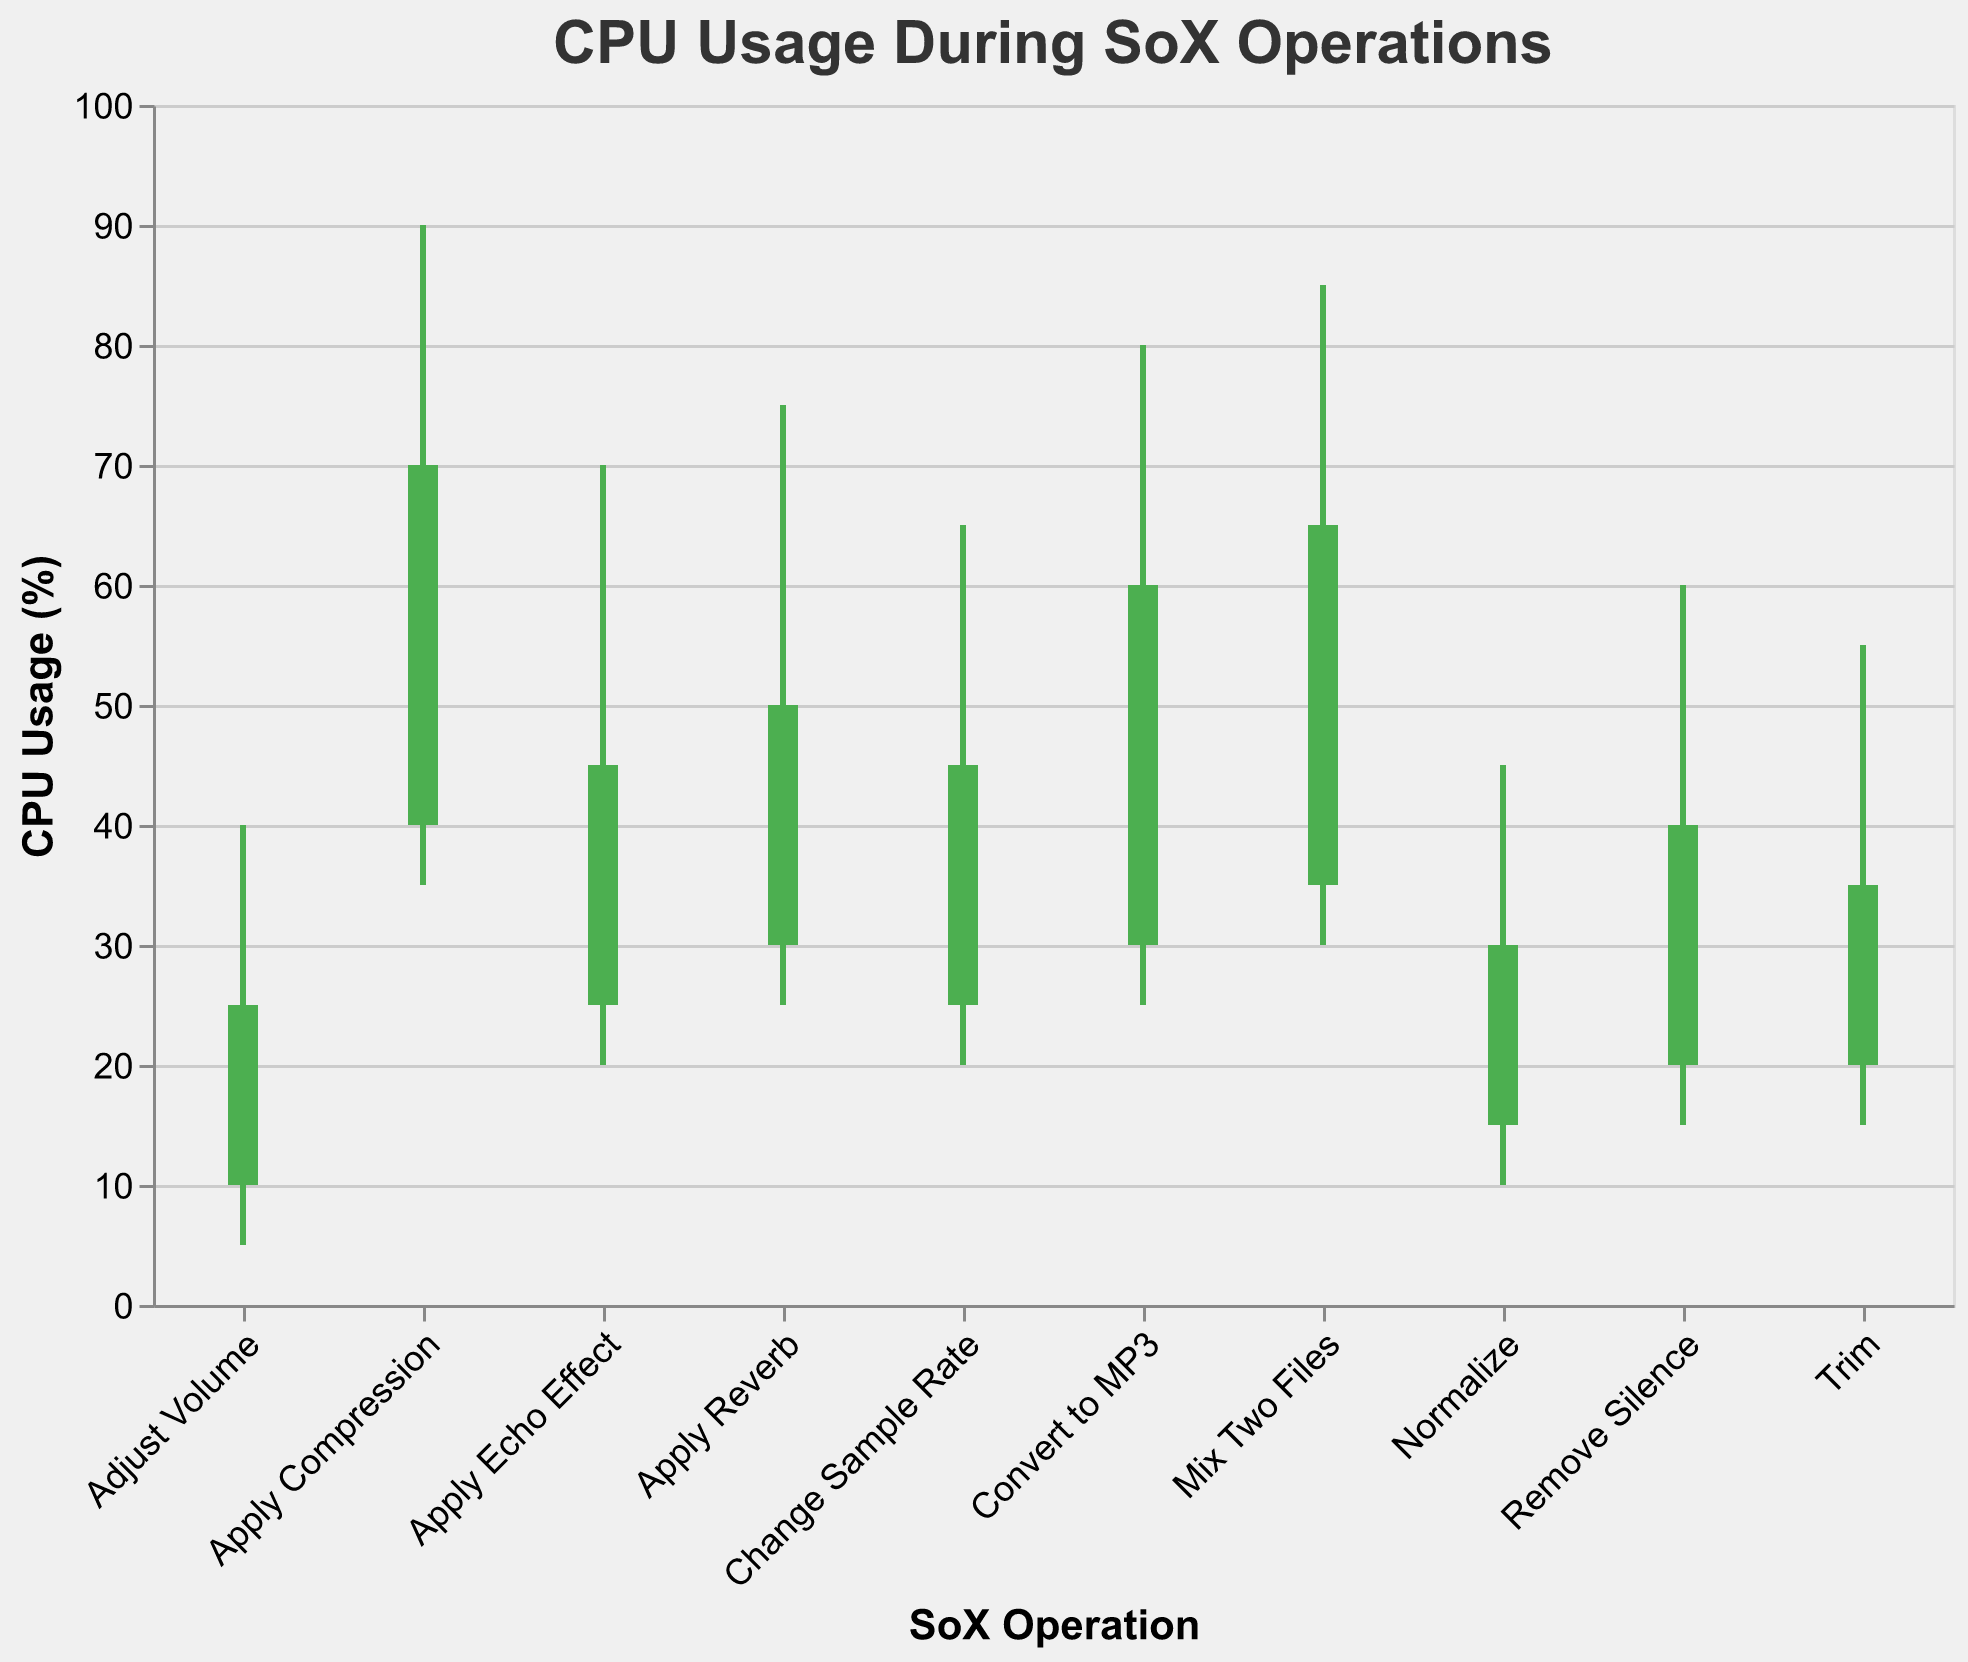What is the title of the chart? The title is prominently displayed at the top of the chart and reads "CPU Usage During SoX Operations".
Answer: CPU Usage During SoX Operations What are the y-axis and x-axis titles in the chart? The y-axis title is shown along the vertical axis as "CPU Usage (%)", and the x-axis title is along the horizontal axis as "SoX Operation".
Answer: CPU Usage (%) and SoX Operation Which SoX operation has the highest peak CPU usage? By looking at the highest point of the bars (High value) for each operation, the "Apply Compression" operation reaches the highest peak at 90%.
Answer: Apply Compression What is the lowest CPU usage recorded during the "Convert to MP3" operation? The lowest CPU usage for the "Convert to MP3" operation is indicated by the Low value, which is 25%.
Answer: 25% Which operation has a higher closing CPU usage, "Trim" or "Adjust Volume"? By comparing the Close values of both operations, "Trim" has a Close value of 35% while "Adjust Volume" has a Close value of 25%, making "Trim" higher.
Answer: Trim What is the average of the peak CPU usages (High values) recorded across all operations? To find the average, sum all the peak CPU usages (45, 55, 80, 70, 40, 85, 75, 60, 90, 65) which is 665, and divide by the number of operations, 10. So, 665 ÷ 10 = 66.5%.
Answer: 66.5% How does the CPU usage close value for "Mix Two Files" compare to "Change Sample Rate"? The Close value for "Mix Two Files" is 65%, whereas for "Change Sample Rate" it is 45%. Thus, "Mix Two Files" has a higher close value by 20%.
Answer: 20% Which operation shows an increase in CPU usage from open to close? Operations where the Close value is higher than the Open value are considered: "Normalize" (15 to 30), "Trim" (20 to 35), "Convert to MP3" (30 to 60), "Apply Echo Effect" (25 to 45), "Mix Two Files" (35 to 65), "Remove Silence" (20 to 40), and "Apply Compression" (40 to 70).
Answer: Normalize, Trim, Convert to MP3, Apply Echo Effect, Mix Two Files, Remove Silence, Apply Compression During the "Apply Reverb" operation, what is the range of the CPU usage? The range is calculated by subtracting the Low value from the High value (75 - 25), which results in a range of 50%.
Answer: 50% Which SoX operation demonstrates the smallest range of CPU usage? The operation with the smallest range is determined by identifying the smallest difference between High and Low values. The "Adjust Volume" operation has the smallest range, with High 40% and Low 5%, resulting in 35%.
Answer: Adjust Volume 